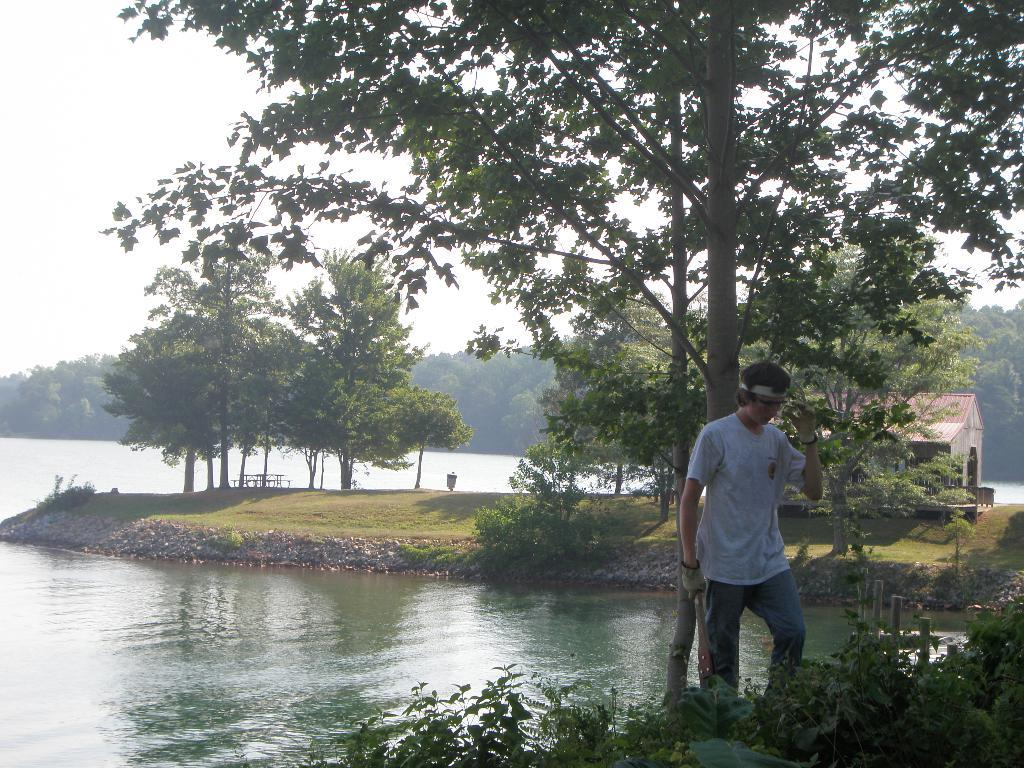Who is present on the right side of the image? There is a man standing on the right side of the image. What type of vegetation can be seen in the image? There are plants and trees in the image. What is the water feature in the image? The water is visible in the image. What is visible at the top of the image? The sky is visible at the top of the image. What type of thing is the farmer holding in the image? There is no farmer present in the image, and therefore no such object can be observed. 